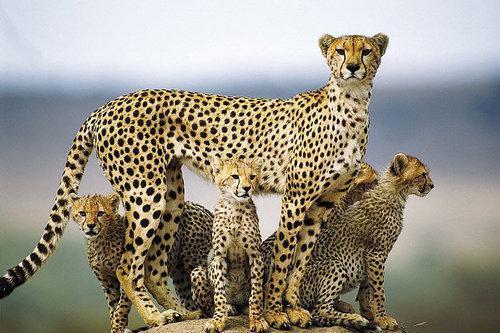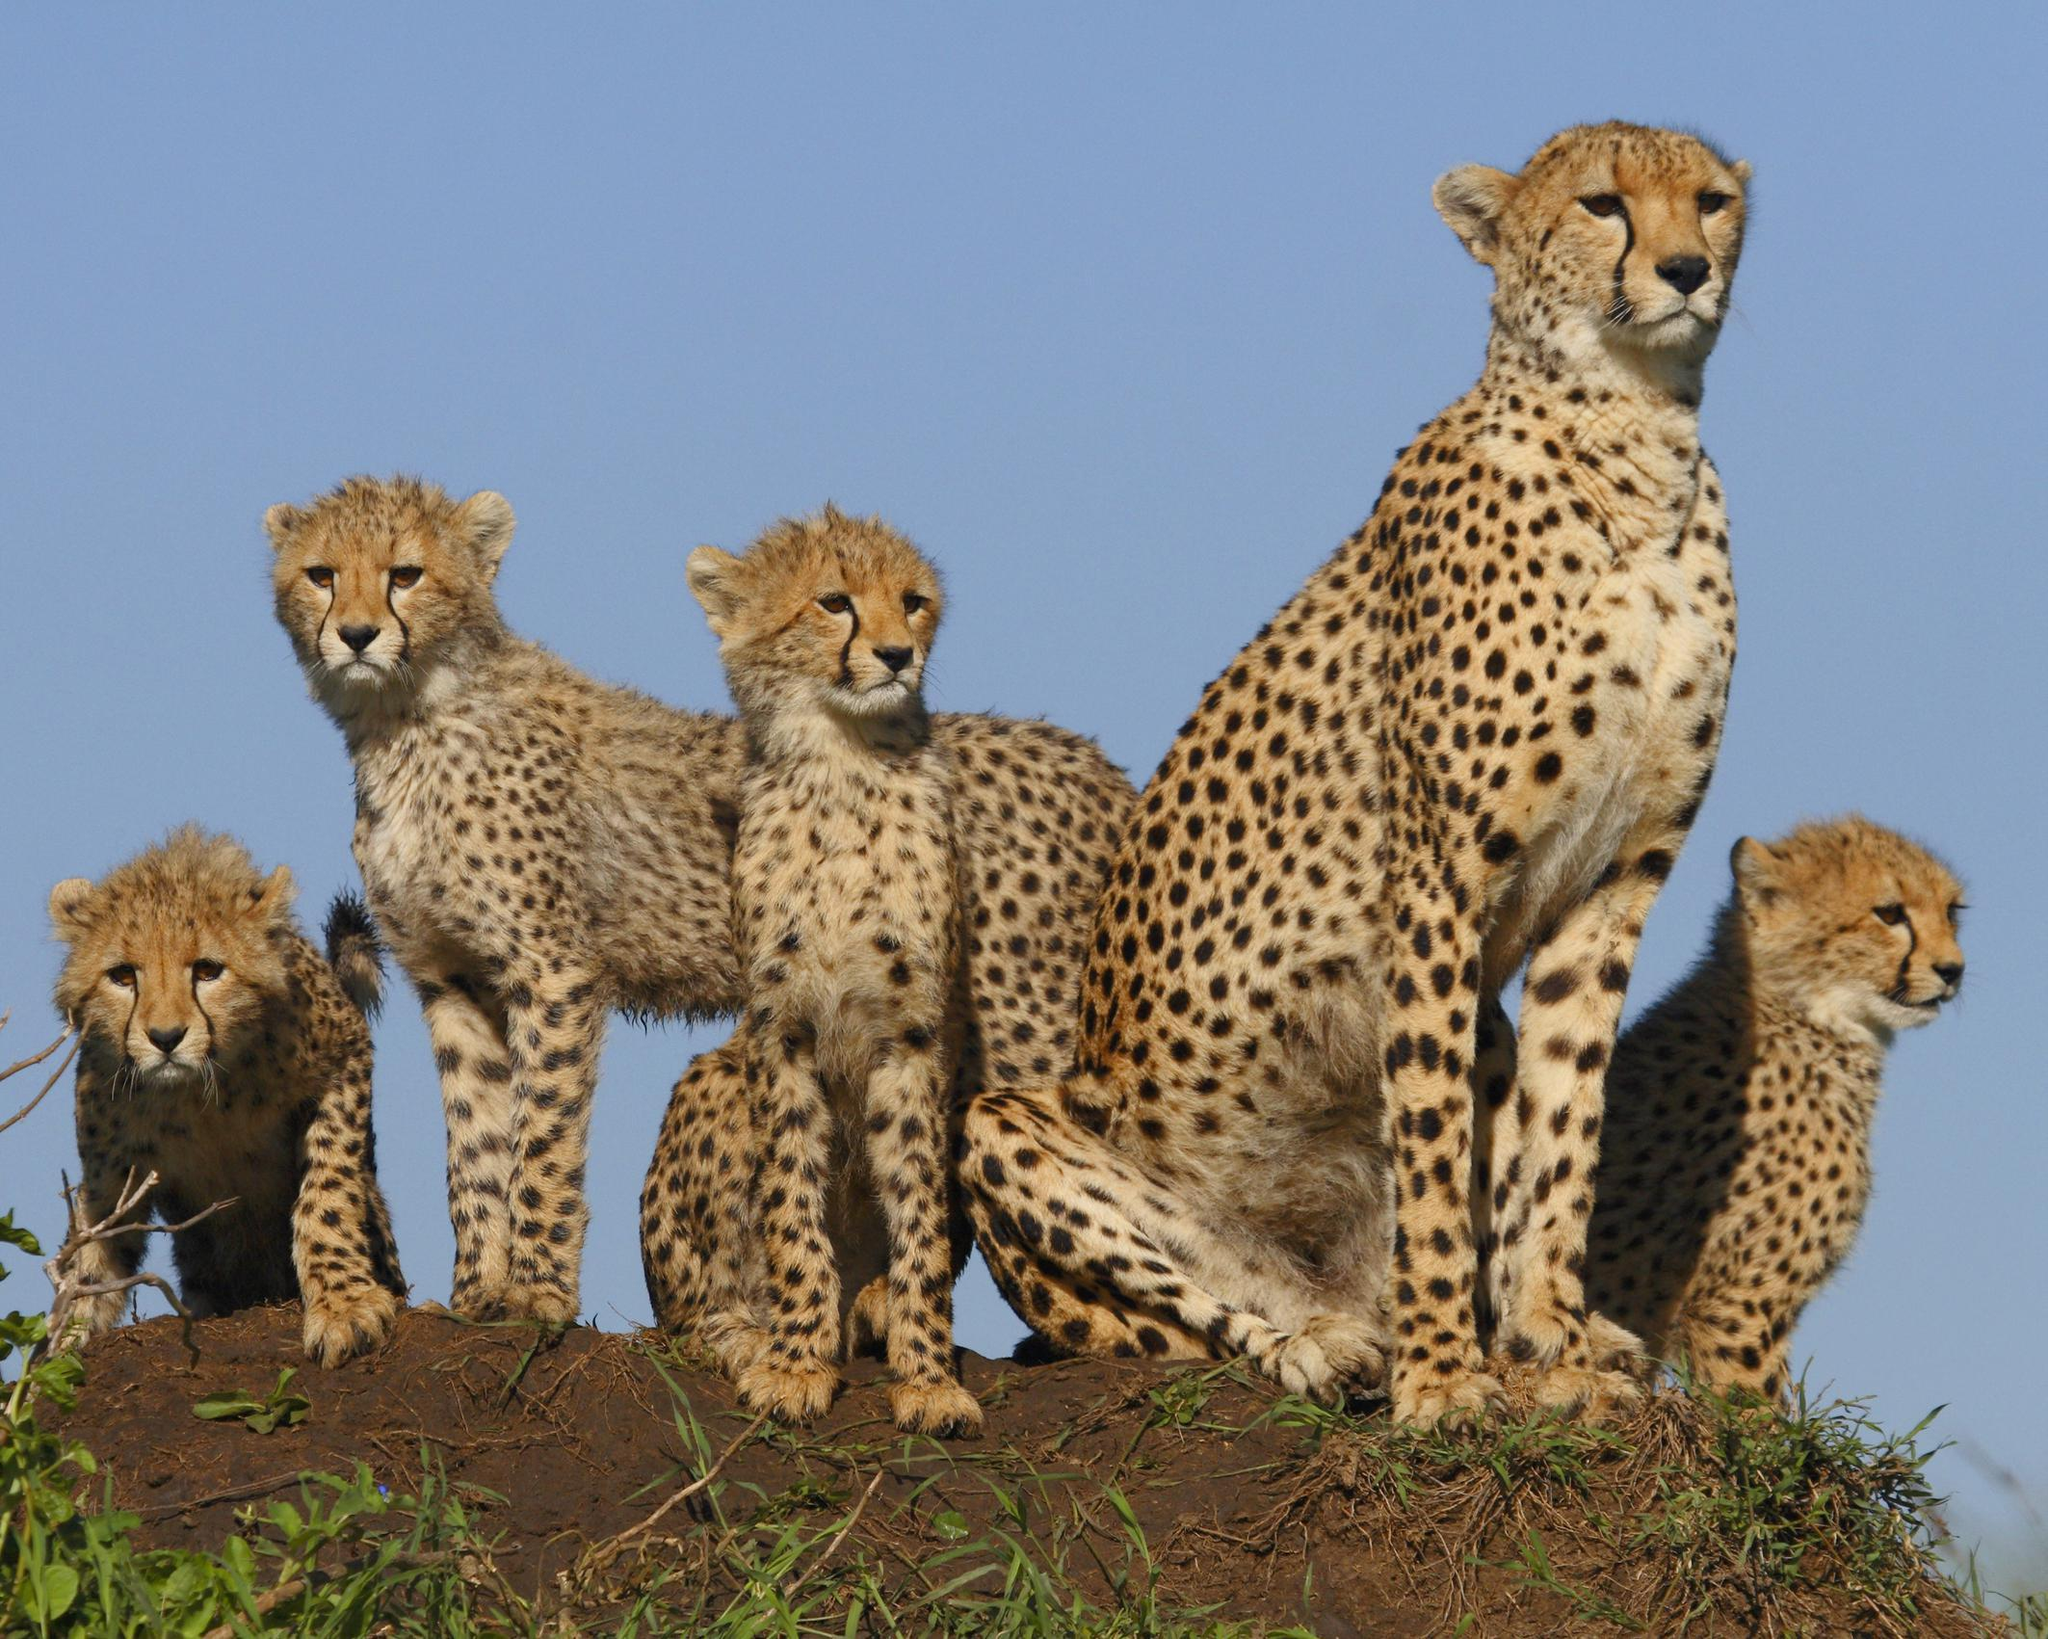The first image is the image on the left, the second image is the image on the right. Evaluate the accuracy of this statement regarding the images: "Each image shows exactly two cheetahs.". Is it true? Answer yes or no. No. 